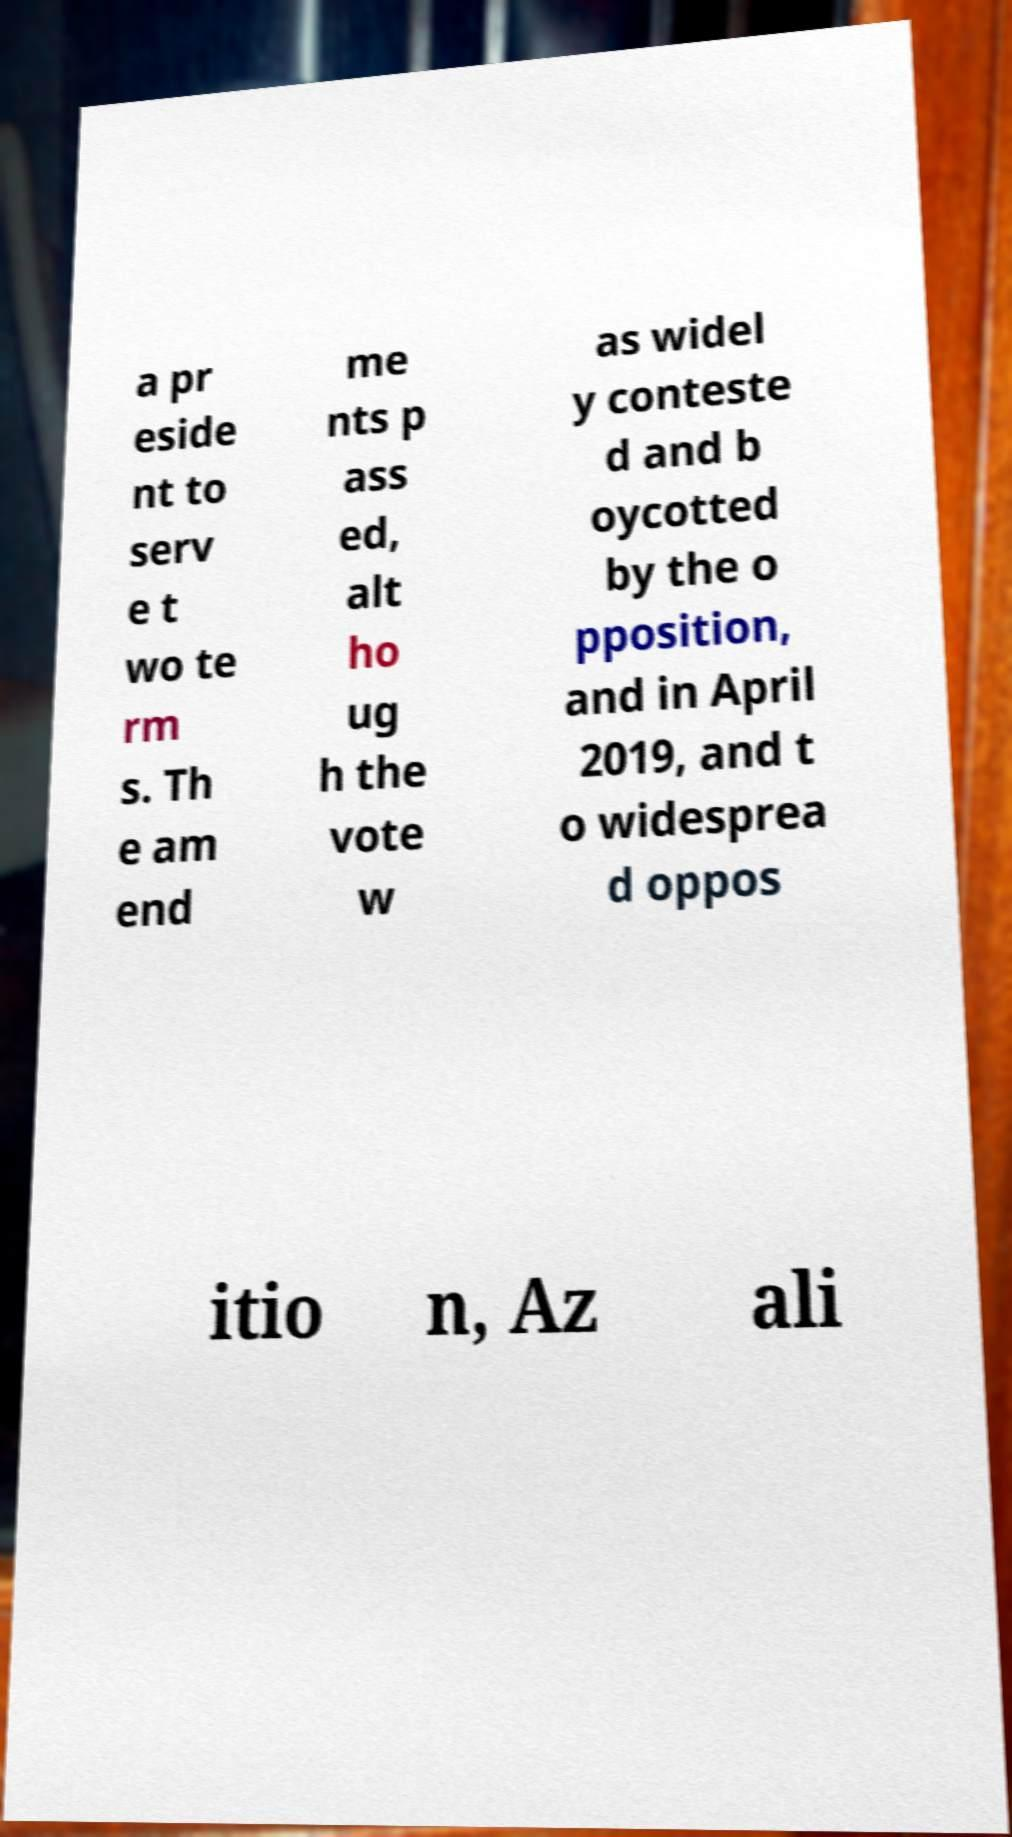I need the written content from this picture converted into text. Can you do that? a pr eside nt to serv e t wo te rm s. Th e am end me nts p ass ed, alt ho ug h the vote w as widel y conteste d and b oycotted by the o pposition, and in April 2019, and t o widesprea d oppos itio n, Az ali 